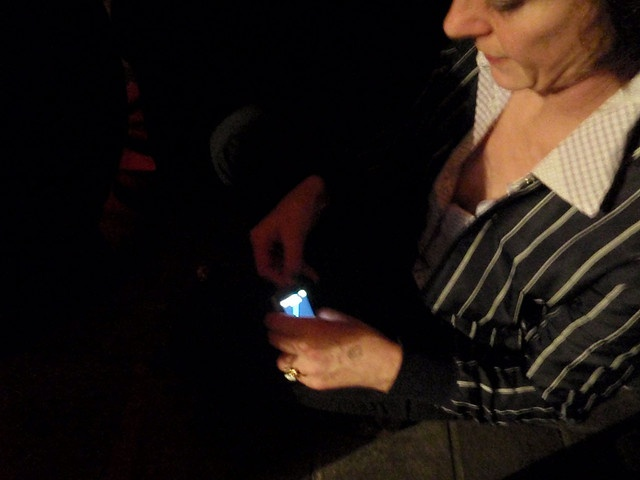Describe the objects in this image and their specific colors. I can see people in black, maroon, salmon, and tan tones and cell phone in black, white, lightblue, and gray tones in this image. 